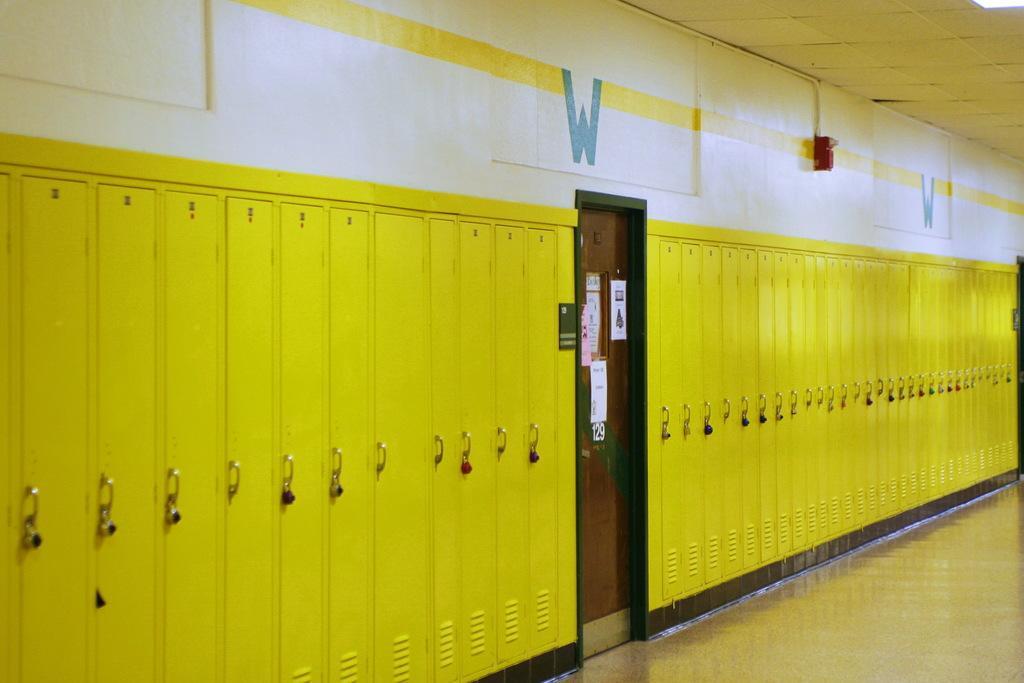Could you give a brief overview of what you see in this image? In this image, we can see the wall with some locks. We can also see a door and some posters. We can also see an object attached to the wall. We can see the ground and the roof. 